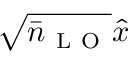<formula> <loc_0><loc_0><loc_500><loc_500>\sqrt { \bar { n } _ { L O } } \hat { x }</formula> 